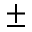<formula> <loc_0><loc_0><loc_500><loc_500>\pm</formula> 